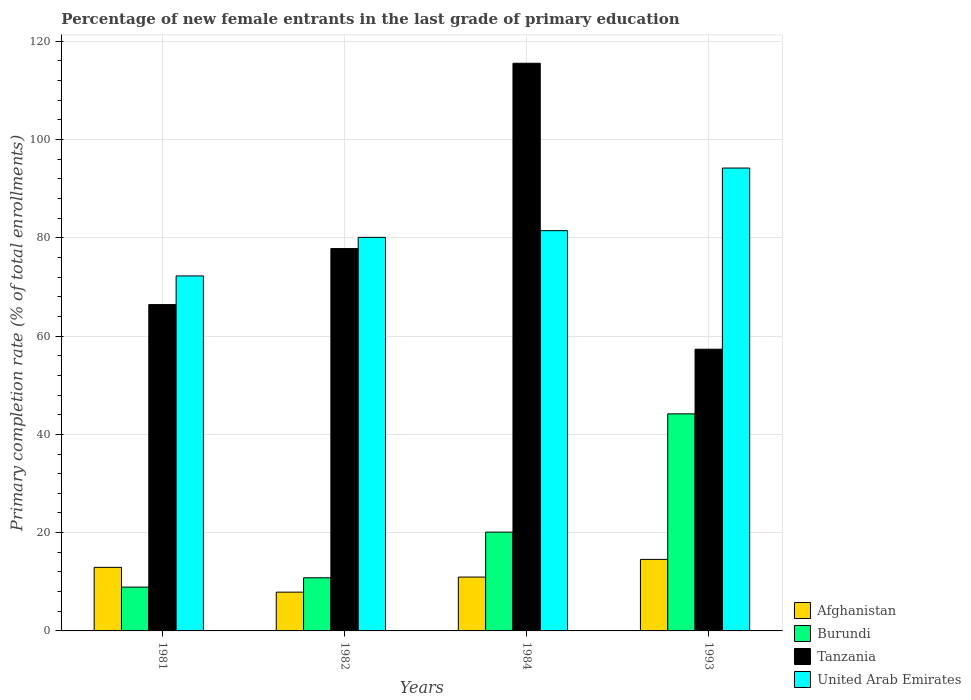How many different coloured bars are there?
Your answer should be compact. 4. Are the number of bars per tick equal to the number of legend labels?
Provide a short and direct response. Yes. Are the number of bars on each tick of the X-axis equal?
Your response must be concise. Yes. How many bars are there on the 4th tick from the left?
Offer a very short reply. 4. What is the label of the 1st group of bars from the left?
Provide a succinct answer. 1981. What is the percentage of new female entrants in United Arab Emirates in 1984?
Ensure brevity in your answer.  81.46. Across all years, what is the maximum percentage of new female entrants in Burundi?
Provide a succinct answer. 44.18. Across all years, what is the minimum percentage of new female entrants in Afghanistan?
Provide a short and direct response. 7.89. In which year was the percentage of new female entrants in United Arab Emirates maximum?
Give a very brief answer. 1993. In which year was the percentage of new female entrants in Afghanistan minimum?
Make the answer very short. 1982. What is the total percentage of new female entrants in Tanzania in the graph?
Give a very brief answer. 317.08. What is the difference between the percentage of new female entrants in United Arab Emirates in 1981 and that in 1993?
Give a very brief answer. -21.95. What is the difference between the percentage of new female entrants in Tanzania in 1982 and the percentage of new female entrants in United Arab Emirates in 1984?
Your response must be concise. -3.65. What is the average percentage of new female entrants in Tanzania per year?
Provide a short and direct response. 79.27. In the year 1984, what is the difference between the percentage of new female entrants in Tanzania and percentage of new female entrants in Afghanistan?
Keep it short and to the point. 104.56. In how many years, is the percentage of new female entrants in Tanzania greater than 116 %?
Give a very brief answer. 0. What is the ratio of the percentage of new female entrants in Burundi in 1981 to that in 1982?
Offer a terse response. 0.82. Is the difference between the percentage of new female entrants in Tanzania in 1981 and 1984 greater than the difference between the percentage of new female entrants in Afghanistan in 1981 and 1984?
Provide a short and direct response. No. What is the difference between the highest and the second highest percentage of new female entrants in Burundi?
Offer a terse response. 24.07. What is the difference between the highest and the lowest percentage of new female entrants in Burundi?
Keep it short and to the point. 35.26. Is it the case that in every year, the sum of the percentage of new female entrants in Burundi and percentage of new female entrants in Afghanistan is greater than the sum of percentage of new female entrants in Tanzania and percentage of new female entrants in United Arab Emirates?
Provide a short and direct response. No. What does the 4th bar from the left in 1993 represents?
Your answer should be very brief. United Arab Emirates. What does the 2nd bar from the right in 1982 represents?
Make the answer very short. Tanzania. Is it the case that in every year, the sum of the percentage of new female entrants in Tanzania and percentage of new female entrants in United Arab Emirates is greater than the percentage of new female entrants in Burundi?
Provide a short and direct response. Yes. How many bars are there?
Provide a succinct answer. 16. Are all the bars in the graph horizontal?
Your answer should be very brief. No. What is the difference between two consecutive major ticks on the Y-axis?
Your answer should be compact. 20. Are the values on the major ticks of Y-axis written in scientific E-notation?
Provide a short and direct response. No. Where does the legend appear in the graph?
Ensure brevity in your answer.  Bottom right. How are the legend labels stacked?
Keep it short and to the point. Vertical. What is the title of the graph?
Offer a terse response. Percentage of new female entrants in the last grade of primary education. What is the label or title of the Y-axis?
Give a very brief answer. Primary completion rate (% of total enrollments). What is the Primary completion rate (% of total enrollments) in Afghanistan in 1981?
Offer a terse response. 12.94. What is the Primary completion rate (% of total enrollments) of Burundi in 1981?
Provide a succinct answer. 8.92. What is the Primary completion rate (% of total enrollments) of Tanzania in 1981?
Offer a terse response. 66.41. What is the Primary completion rate (% of total enrollments) in United Arab Emirates in 1981?
Provide a succinct answer. 72.25. What is the Primary completion rate (% of total enrollments) in Afghanistan in 1982?
Provide a short and direct response. 7.89. What is the Primary completion rate (% of total enrollments) of Burundi in 1982?
Keep it short and to the point. 10.82. What is the Primary completion rate (% of total enrollments) in Tanzania in 1982?
Provide a short and direct response. 77.81. What is the Primary completion rate (% of total enrollments) of United Arab Emirates in 1982?
Provide a short and direct response. 80.09. What is the Primary completion rate (% of total enrollments) in Afghanistan in 1984?
Give a very brief answer. 10.96. What is the Primary completion rate (% of total enrollments) in Burundi in 1984?
Your answer should be compact. 20.11. What is the Primary completion rate (% of total enrollments) in Tanzania in 1984?
Provide a short and direct response. 115.52. What is the Primary completion rate (% of total enrollments) of United Arab Emirates in 1984?
Give a very brief answer. 81.46. What is the Primary completion rate (% of total enrollments) in Afghanistan in 1993?
Offer a terse response. 14.56. What is the Primary completion rate (% of total enrollments) of Burundi in 1993?
Make the answer very short. 44.18. What is the Primary completion rate (% of total enrollments) of Tanzania in 1993?
Provide a short and direct response. 57.33. What is the Primary completion rate (% of total enrollments) in United Arab Emirates in 1993?
Offer a very short reply. 94.2. Across all years, what is the maximum Primary completion rate (% of total enrollments) in Afghanistan?
Your answer should be compact. 14.56. Across all years, what is the maximum Primary completion rate (% of total enrollments) in Burundi?
Provide a short and direct response. 44.18. Across all years, what is the maximum Primary completion rate (% of total enrollments) in Tanzania?
Your response must be concise. 115.52. Across all years, what is the maximum Primary completion rate (% of total enrollments) in United Arab Emirates?
Ensure brevity in your answer.  94.2. Across all years, what is the minimum Primary completion rate (% of total enrollments) of Afghanistan?
Your response must be concise. 7.89. Across all years, what is the minimum Primary completion rate (% of total enrollments) in Burundi?
Your answer should be very brief. 8.92. Across all years, what is the minimum Primary completion rate (% of total enrollments) in Tanzania?
Your response must be concise. 57.33. Across all years, what is the minimum Primary completion rate (% of total enrollments) in United Arab Emirates?
Provide a short and direct response. 72.25. What is the total Primary completion rate (% of total enrollments) of Afghanistan in the graph?
Your answer should be compact. 46.35. What is the total Primary completion rate (% of total enrollments) of Burundi in the graph?
Provide a succinct answer. 84.02. What is the total Primary completion rate (% of total enrollments) in Tanzania in the graph?
Your answer should be compact. 317.08. What is the total Primary completion rate (% of total enrollments) in United Arab Emirates in the graph?
Keep it short and to the point. 327.99. What is the difference between the Primary completion rate (% of total enrollments) of Afghanistan in 1981 and that in 1982?
Your answer should be compact. 5.05. What is the difference between the Primary completion rate (% of total enrollments) in Burundi in 1981 and that in 1982?
Make the answer very short. -1.9. What is the difference between the Primary completion rate (% of total enrollments) in Tanzania in 1981 and that in 1982?
Offer a terse response. -11.4. What is the difference between the Primary completion rate (% of total enrollments) of United Arab Emirates in 1981 and that in 1982?
Ensure brevity in your answer.  -7.84. What is the difference between the Primary completion rate (% of total enrollments) in Afghanistan in 1981 and that in 1984?
Your answer should be very brief. 1.98. What is the difference between the Primary completion rate (% of total enrollments) in Burundi in 1981 and that in 1984?
Your response must be concise. -11.19. What is the difference between the Primary completion rate (% of total enrollments) of Tanzania in 1981 and that in 1984?
Provide a succinct answer. -49.11. What is the difference between the Primary completion rate (% of total enrollments) of United Arab Emirates in 1981 and that in 1984?
Provide a succinct answer. -9.21. What is the difference between the Primary completion rate (% of total enrollments) of Afghanistan in 1981 and that in 1993?
Your response must be concise. -1.62. What is the difference between the Primary completion rate (% of total enrollments) of Burundi in 1981 and that in 1993?
Ensure brevity in your answer.  -35.26. What is the difference between the Primary completion rate (% of total enrollments) of Tanzania in 1981 and that in 1993?
Give a very brief answer. 9.08. What is the difference between the Primary completion rate (% of total enrollments) in United Arab Emirates in 1981 and that in 1993?
Your response must be concise. -21.95. What is the difference between the Primary completion rate (% of total enrollments) of Afghanistan in 1982 and that in 1984?
Provide a short and direct response. -3.07. What is the difference between the Primary completion rate (% of total enrollments) of Burundi in 1982 and that in 1984?
Make the answer very short. -9.29. What is the difference between the Primary completion rate (% of total enrollments) of Tanzania in 1982 and that in 1984?
Offer a very short reply. -37.71. What is the difference between the Primary completion rate (% of total enrollments) of United Arab Emirates in 1982 and that in 1984?
Provide a short and direct response. -1.37. What is the difference between the Primary completion rate (% of total enrollments) of Afghanistan in 1982 and that in 1993?
Your response must be concise. -6.67. What is the difference between the Primary completion rate (% of total enrollments) in Burundi in 1982 and that in 1993?
Offer a very short reply. -33.36. What is the difference between the Primary completion rate (% of total enrollments) of Tanzania in 1982 and that in 1993?
Ensure brevity in your answer.  20.48. What is the difference between the Primary completion rate (% of total enrollments) of United Arab Emirates in 1982 and that in 1993?
Provide a short and direct response. -14.1. What is the difference between the Primary completion rate (% of total enrollments) of Afghanistan in 1984 and that in 1993?
Your response must be concise. -3.6. What is the difference between the Primary completion rate (% of total enrollments) of Burundi in 1984 and that in 1993?
Make the answer very short. -24.07. What is the difference between the Primary completion rate (% of total enrollments) of Tanzania in 1984 and that in 1993?
Provide a short and direct response. 58.19. What is the difference between the Primary completion rate (% of total enrollments) of United Arab Emirates in 1984 and that in 1993?
Provide a succinct answer. -12.74. What is the difference between the Primary completion rate (% of total enrollments) of Afghanistan in 1981 and the Primary completion rate (% of total enrollments) of Burundi in 1982?
Ensure brevity in your answer.  2.12. What is the difference between the Primary completion rate (% of total enrollments) of Afghanistan in 1981 and the Primary completion rate (% of total enrollments) of Tanzania in 1982?
Give a very brief answer. -64.87. What is the difference between the Primary completion rate (% of total enrollments) of Afghanistan in 1981 and the Primary completion rate (% of total enrollments) of United Arab Emirates in 1982?
Your answer should be very brief. -67.15. What is the difference between the Primary completion rate (% of total enrollments) in Burundi in 1981 and the Primary completion rate (% of total enrollments) in Tanzania in 1982?
Offer a very short reply. -68.89. What is the difference between the Primary completion rate (% of total enrollments) in Burundi in 1981 and the Primary completion rate (% of total enrollments) in United Arab Emirates in 1982?
Make the answer very short. -71.17. What is the difference between the Primary completion rate (% of total enrollments) in Tanzania in 1981 and the Primary completion rate (% of total enrollments) in United Arab Emirates in 1982?
Your answer should be compact. -13.68. What is the difference between the Primary completion rate (% of total enrollments) of Afghanistan in 1981 and the Primary completion rate (% of total enrollments) of Burundi in 1984?
Provide a succinct answer. -7.17. What is the difference between the Primary completion rate (% of total enrollments) in Afghanistan in 1981 and the Primary completion rate (% of total enrollments) in Tanzania in 1984?
Your answer should be compact. -102.59. What is the difference between the Primary completion rate (% of total enrollments) in Afghanistan in 1981 and the Primary completion rate (% of total enrollments) in United Arab Emirates in 1984?
Your answer should be compact. -68.52. What is the difference between the Primary completion rate (% of total enrollments) of Burundi in 1981 and the Primary completion rate (% of total enrollments) of Tanzania in 1984?
Provide a short and direct response. -106.61. What is the difference between the Primary completion rate (% of total enrollments) of Burundi in 1981 and the Primary completion rate (% of total enrollments) of United Arab Emirates in 1984?
Provide a short and direct response. -72.54. What is the difference between the Primary completion rate (% of total enrollments) in Tanzania in 1981 and the Primary completion rate (% of total enrollments) in United Arab Emirates in 1984?
Ensure brevity in your answer.  -15.05. What is the difference between the Primary completion rate (% of total enrollments) in Afghanistan in 1981 and the Primary completion rate (% of total enrollments) in Burundi in 1993?
Keep it short and to the point. -31.24. What is the difference between the Primary completion rate (% of total enrollments) in Afghanistan in 1981 and the Primary completion rate (% of total enrollments) in Tanzania in 1993?
Give a very brief answer. -44.39. What is the difference between the Primary completion rate (% of total enrollments) of Afghanistan in 1981 and the Primary completion rate (% of total enrollments) of United Arab Emirates in 1993?
Ensure brevity in your answer.  -81.26. What is the difference between the Primary completion rate (% of total enrollments) of Burundi in 1981 and the Primary completion rate (% of total enrollments) of Tanzania in 1993?
Give a very brief answer. -48.41. What is the difference between the Primary completion rate (% of total enrollments) in Burundi in 1981 and the Primary completion rate (% of total enrollments) in United Arab Emirates in 1993?
Keep it short and to the point. -85.28. What is the difference between the Primary completion rate (% of total enrollments) of Tanzania in 1981 and the Primary completion rate (% of total enrollments) of United Arab Emirates in 1993?
Your response must be concise. -27.78. What is the difference between the Primary completion rate (% of total enrollments) in Afghanistan in 1982 and the Primary completion rate (% of total enrollments) in Burundi in 1984?
Give a very brief answer. -12.22. What is the difference between the Primary completion rate (% of total enrollments) in Afghanistan in 1982 and the Primary completion rate (% of total enrollments) in Tanzania in 1984?
Ensure brevity in your answer.  -107.64. What is the difference between the Primary completion rate (% of total enrollments) of Afghanistan in 1982 and the Primary completion rate (% of total enrollments) of United Arab Emirates in 1984?
Ensure brevity in your answer.  -73.57. What is the difference between the Primary completion rate (% of total enrollments) in Burundi in 1982 and the Primary completion rate (% of total enrollments) in Tanzania in 1984?
Provide a succinct answer. -104.71. What is the difference between the Primary completion rate (% of total enrollments) of Burundi in 1982 and the Primary completion rate (% of total enrollments) of United Arab Emirates in 1984?
Your answer should be compact. -70.64. What is the difference between the Primary completion rate (% of total enrollments) of Tanzania in 1982 and the Primary completion rate (% of total enrollments) of United Arab Emirates in 1984?
Your response must be concise. -3.65. What is the difference between the Primary completion rate (% of total enrollments) in Afghanistan in 1982 and the Primary completion rate (% of total enrollments) in Burundi in 1993?
Ensure brevity in your answer.  -36.29. What is the difference between the Primary completion rate (% of total enrollments) in Afghanistan in 1982 and the Primary completion rate (% of total enrollments) in Tanzania in 1993?
Offer a terse response. -49.44. What is the difference between the Primary completion rate (% of total enrollments) in Afghanistan in 1982 and the Primary completion rate (% of total enrollments) in United Arab Emirates in 1993?
Offer a terse response. -86.31. What is the difference between the Primary completion rate (% of total enrollments) in Burundi in 1982 and the Primary completion rate (% of total enrollments) in Tanzania in 1993?
Offer a very short reply. -46.51. What is the difference between the Primary completion rate (% of total enrollments) in Burundi in 1982 and the Primary completion rate (% of total enrollments) in United Arab Emirates in 1993?
Ensure brevity in your answer.  -83.38. What is the difference between the Primary completion rate (% of total enrollments) in Tanzania in 1982 and the Primary completion rate (% of total enrollments) in United Arab Emirates in 1993?
Offer a very short reply. -16.38. What is the difference between the Primary completion rate (% of total enrollments) of Afghanistan in 1984 and the Primary completion rate (% of total enrollments) of Burundi in 1993?
Offer a terse response. -33.22. What is the difference between the Primary completion rate (% of total enrollments) of Afghanistan in 1984 and the Primary completion rate (% of total enrollments) of Tanzania in 1993?
Make the answer very short. -46.37. What is the difference between the Primary completion rate (% of total enrollments) in Afghanistan in 1984 and the Primary completion rate (% of total enrollments) in United Arab Emirates in 1993?
Offer a terse response. -83.24. What is the difference between the Primary completion rate (% of total enrollments) in Burundi in 1984 and the Primary completion rate (% of total enrollments) in Tanzania in 1993?
Provide a short and direct response. -37.23. What is the difference between the Primary completion rate (% of total enrollments) in Burundi in 1984 and the Primary completion rate (% of total enrollments) in United Arab Emirates in 1993?
Your answer should be compact. -74.09. What is the difference between the Primary completion rate (% of total enrollments) of Tanzania in 1984 and the Primary completion rate (% of total enrollments) of United Arab Emirates in 1993?
Keep it short and to the point. 21.33. What is the average Primary completion rate (% of total enrollments) of Afghanistan per year?
Your answer should be very brief. 11.59. What is the average Primary completion rate (% of total enrollments) of Burundi per year?
Your answer should be compact. 21. What is the average Primary completion rate (% of total enrollments) of Tanzania per year?
Give a very brief answer. 79.27. What is the average Primary completion rate (% of total enrollments) in United Arab Emirates per year?
Your response must be concise. 82. In the year 1981, what is the difference between the Primary completion rate (% of total enrollments) of Afghanistan and Primary completion rate (% of total enrollments) of Burundi?
Give a very brief answer. 4.02. In the year 1981, what is the difference between the Primary completion rate (% of total enrollments) of Afghanistan and Primary completion rate (% of total enrollments) of Tanzania?
Ensure brevity in your answer.  -53.47. In the year 1981, what is the difference between the Primary completion rate (% of total enrollments) of Afghanistan and Primary completion rate (% of total enrollments) of United Arab Emirates?
Your answer should be compact. -59.31. In the year 1981, what is the difference between the Primary completion rate (% of total enrollments) in Burundi and Primary completion rate (% of total enrollments) in Tanzania?
Ensure brevity in your answer.  -57.49. In the year 1981, what is the difference between the Primary completion rate (% of total enrollments) in Burundi and Primary completion rate (% of total enrollments) in United Arab Emirates?
Your answer should be very brief. -63.33. In the year 1981, what is the difference between the Primary completion rate (% of total enrollments) of Tanzania and Primary completion rate (% of total enrollments) of United Arab Emirates?
Keep it short and to the point. -5.84. In the year 1982, what is the difference between the Primary completion rate (% of total enrollments) in Afghanistan and Primary completion rate (% of total enrollments) in Burundi?
Your response must be concise. -2.93. In the year 1982, what is the difference between the Primary completion rate (% of total enrollments) of Afghanistan and Primary completion rate (% of total enrollments) of Tanzania?
Keep it short and to the point. -69.92. In the year 1982, what is the difference between the Primary completion rate (% of total enrollments) of Afghanistan and Primary completion rate (% of total enrollments) of United Arab Emirates?
Your answer should be compact. -72.2. In the year 1982, what is the difference between the Primary completion rate (% of total enrollments) in Burundi and Primary completion rate (% of total enrollments) in Tanzania?
Provide a succinct answer. -66.99. In the year 1982, what is the difference between the Primary completion rate (% of total enrollments) of Burundi and Primary completion rate (% of total enrollments) of United Arab Emirates?
Offer a terse response. -69.27. In the year 1982, what is the difference between the Primary completion rate (% of total enrollments) of Tanzania and Primary completion rate (% of total enrollments) of United Arab Emirates?
Provide a short and direct response. -2.28. In the year 1984, what is the difference between the Primary completion rate (% of total enrollments) of Afghanistan and Primary completion rate (% of total enrollments) of Burundi?
Your response must be concise. -9.15. In the year 1984, what is the difference between the Primary completion rate (% of total enrollments) of Afghanistan and Primary completion rate (% of total enrollments) of Tanzania?
Offer a very short reply. -104.56. In the year 1984, what is the difference between the Primary completion rate (% of total enrollments) in Afghanistan and Primary completion rate (% of total enrollments) in United Arab Emirates?
Provide a short and direct response. -70.5. In the year 1984, what is the difference between the Primary completion rate (% of total enrollments) in Burundi and Primary completion rate (% of total enrollments) in Tanzania?
Make the answer very short. -95.42. In the year 1984, what is the difference between the Primary completion rate (% of total enrollments) of Burundi and Primary completion rate (% of total enrollments) of United Arab Emirates?
Your response must be concise. -61.35. In the year 1984, what is the difference between the Primary completion rate (% of total enrollments) of Tanzania and Primary completion rate (% of total enrollments) of United Arab Emirates?
Offer a very short reply. 34.07. In the year 1993, what is the difference between the Primary completion rate (% of total enrollments) in Afghanistan and Primary completion rate (% of total enrollments) in Burundi?
Provide a short and direct response. -29.62. In the year 1993, what is the difference between the Primary completion rate (% of total enrollments) in Afghanistan and Primary completion rate (% of total enrollments) in Tanzania?
Your answer should be compact. -42.77. In the year 1993, what is the difference between the Primary completion rate (% of total enrollments) of Afghanistan and Primary completion rate (% of total enrollments) of United Arab Emirates?
Give a very brief answer. -79.64. In the year 1993, what is the difference between the Primary completion rate (% of total enrollments) of Burundi and Primary completion rate (% of total enrollments) of Tanzania?
Your answer should be compact. -13.16. In the year 1993, what is the difference between the Primary completion rate (% of total enrollments) in Burundi and Primary completion rate (% of total enrollments) in United Arab Emirates?
Offer a very short reply. -50.02. In the year 1993, what is the difference between the Primary completion rate (% of total enrollments) of Tanzania and Primary completion rate (% of total enrollments) of United Arab Emirates?
Offer a terse response. -36.86. What is the ratio of the Primary completion rate (% of total enrollments) of Afghanistan in 1981 to that in 1982?
Give a very brief answer. 1.64. What is the ratio of the Primary completion rate (% of total enrollments) in Burundi in 1981 to that in 1982?
Ensure brevity in your answer.  0.82. What is the ratio of the Primary completion rate (% of total enrollments) of Tanzania in 1981 to that in 1982?
Your answer should be very brief. 0.85. What is the ratio of the Primary completion rate (% of total enrollments) of United Arab Emirates in 1981 to that in 1982?
Offer a very short reply. 0.9. What is the ratio of the Primary completion rate (% of total enrollments) of Afghanistan in 1981 to that in 1984?
Keep it short and to the point. 1.18. What is the ratio of the Primary completion rate (% of total enrollments) in Burundi in 1981 to that in 1984?
Keep it short and to the point. 0.44. What is the ratio of the Primary completion rate (% of total enrollments) of Tanzania in 1981 to that in 1984?
Provide a succinct answer. 0.57. What is the ratio of the Primary completion rate (% of total enrollments) of United Arab Emirates in 1981 to that in 1984?
Your answer should be compact. 0.89. What is the ratio of the Primary completion rate (% of total enrollments) in Afghanistan in 1981 to that in 1993?
Your answer should be compact. 0.89. What is the ratio of the Primary completion rate (% of total enrollments) of Burundi in 1981 to that in 1993?
Your answer should be compact. 0.2. What is the ratio of the Primary completion rate (% of total enrollments) in Tanzania in 1981 to that in 1993?
Your answer should be compact. 1.16. What is the ratio of the Primary completion rate (% of total enrollments) of United Arab Emirates in 1981 to that in 1993?
Provide a short and direct response. 0.77. What is the ratio of the Primary completion rate (% of total enrollments) of Afghanistan in 1982 to that in 1984?
Your answer should be very brief. 0.72. What is the ratio of the Primary completion rate (% of total enrollments) of Burundi in 1982 to that in 1984?
Provide a succinct answer. 0.54. What is the ratio of the Primary completion rate (% of total enrollments) in Tanzania in 1982 to that in 1984?
Offer a very short reply. 0.67. What is the ratio of the Primary completion rate (% of total enrollments) in United Arab Emirates in 1982 to that in 1984?
Your answer should be compact. 0.98. What is the ratio of the Primary completion rate (% of total enrollments) in Afghanistan in 1982 to that in 1993?
Your answer should be compact. 0.54. What is the ratio of the Primary completion rate (% of total enrollments) in Burundi in 1982 to that in 1993?
Give a very brief answer. 0.24. What is the ratio of the Primary completion rate (% of total enrollments) of Tanzania in 1982 to that in 1993?
Give a very brief answer. 1.36. What is the ratio of the Primary completion rate (% of total enrollments) in United Arab Emirates in 1982 to that in 1993?
Your response must be concise. 0.85. What is the ratio of the Primary completion rate (% of total enrollments) in Afghanistan in 1984 to that in 1993?
Your answer should be compact. 0.75. What is the ratio of the Primary completion rate (% of total enrollments) of Burundi in 1984 to that in 1993?
Provide a short and direct response. 0.46. What is the ratio of the Primary completion rate (% of total enrollments) in Tanzania in 1984 to that in 1993?
Your answer should be compact. 2.02. What is the ratio of the Primary completion rate (% of total enrollments) in United Arab Emirates in 1984 to that in 1993?
Your answer should be compact. 0.86. What is the difference between the highest and the second highest Primary completion rate (% of total enrollments) in Afghanistan?
Ensure brevity in your answer.  1.62. What is the difference between the highest and the second highest Primary completion rate (% of total enrollments) of Burundi?
Provide a short and direct response. 24.07. What is the difference between the highest and the second highest Primary completion rate (% of total enrollments) in Tanzania?
Provide a short and direct response. 37.71. What is the difference between the highest and the second highest Primary completion rate (% of total enrollments) of United Arab Emirates?
Ensure brevity in your answer.  12.74. What is the difference between the highest and the lowest Primary completion rate (% of total enrollments) in Afghanistan?
Provide a succinct answer. 6.67. What is the difference between the highest and the lowest Primary completion rate (% of total enrollments) of Burundi?
Your answer should be compact. 35.26. What is the difference between the highest and the lowest Primary completion rate (% of total enrollments) in Tanzania?
Give a very brief answer. 58.19. What is the difference between the highest and the lowest Primary completion rate (% of total enrollments) of United Arab Emirates?
Your response must be concise. 21.95. 